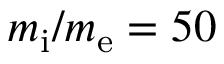<formula> <loc_0><loc_0><loc_500><loc_500>m _ { i } / m _ { e } = 5 0</formula> 